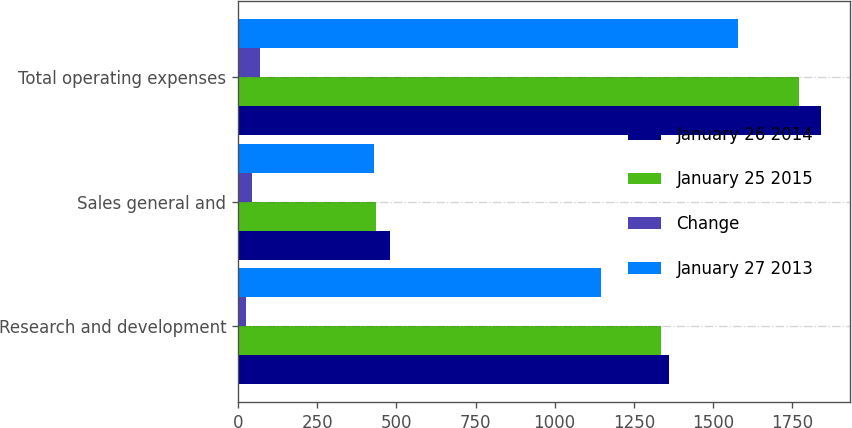Convert chart. <chart><loc_0><loc_0><loc_500><loc_500><stacked_bar_chart><ecel><fcel>Research and development<fcel>Sales general and<fcel>Total operating expenses<nl><fcel>January 26 2014<fcel>1359.7<fcel>480.8<fcel>1840.5<nl><fcel>January 25 2015<fcel>1335.8<fcel>435.7<fcel>1771.5<nl><fcel>Change<fcel>23.9<fcel>45.1<fcel>69<nl><fcel>January 27 2013<fcel>1147.3<fcel>430.8<fcel>1578.1<nl></chart> 